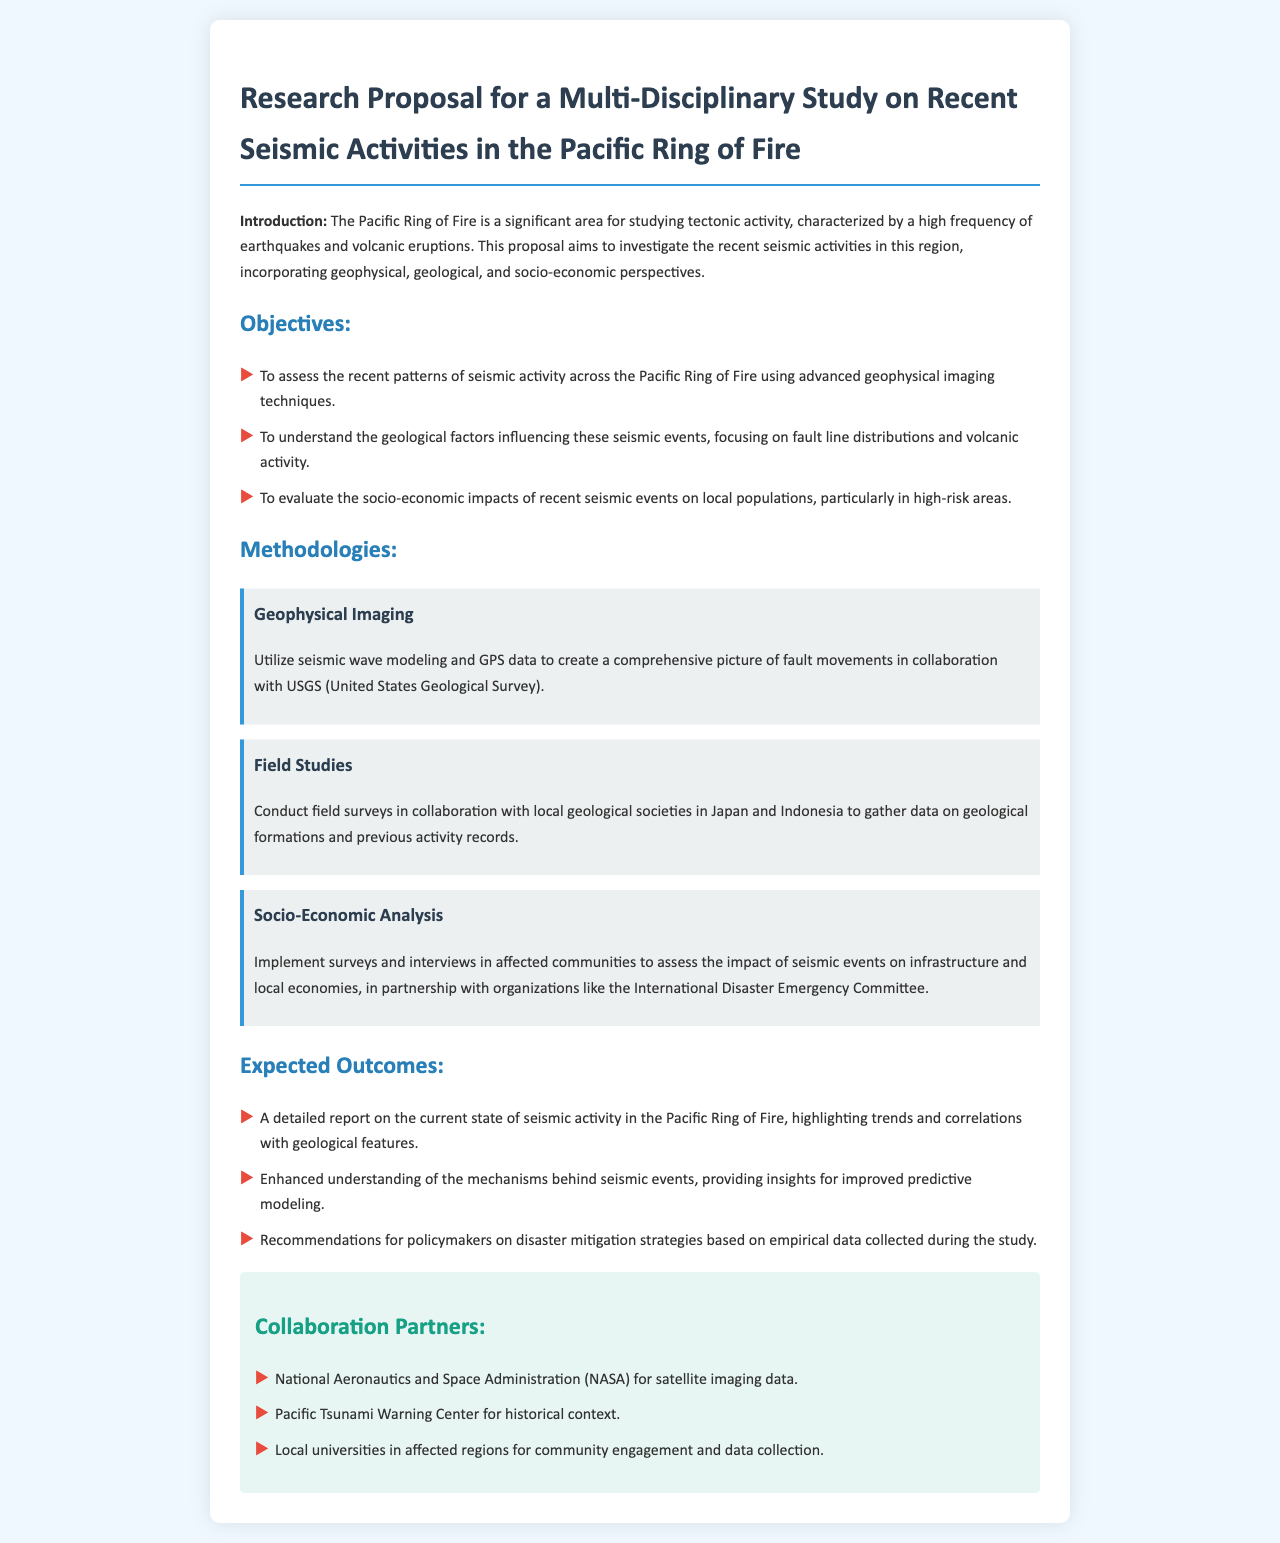What is the main focus of the research proposal? The main focus is to investigate recent seismic activities in the Pacific Ring of Fire.
Answer: Investigate recent seismic activities in the Pacific Ring of Fire What are the three objectives outlined in the proposal? The three objectives are assessing seismic patterns, understanding geological factors, and evaluating socio-economic impacts.
Answer: Assess seismic patterns, understand geological factors, and evaluate socio-economic impacts Which organization will provide satellite imaging data? The organization providing satellite imaging data is NASA.
Answer: NASA What methodologies will be used for field studies? Field studies will involve conducting surveys in collaboration with local geological societies in Japan and Indonesia.
Answer: Conduct surveys in collaboration with local geological societies in Japan and Indonesia What is the expected outcome related to policymakers? The expected outcome includes recommendations for disaster mitigation strategies based on empirical data.
Answer: Recommendations for disaster mitigation strategies How will socio-economic analysis be conducted? Socio-economic analysis will be implemented through surveys and interviews in affected communities.
Answer: Surveys and interviews in affected communities Which two organizations will collaborate for historical context and community engagement? The two organizations are the Pacific Tsunami Warning Center and local universities in affected regions.
Answer: Pacific Tsunami Warning Center and local universities in affected regions What type of report is expected as an outcome of the study? A detailed report on the current state of seismic activity in the Pacific Ring of Fire is expected.
Answer: A detailed report on the current state of seismic activity What specific technique will be utilized for geophysical imaging? Seismic wave modeling and GPS data will be utilized for geophysical imaging.
Answer: Seismic wave modeling and GPS data 